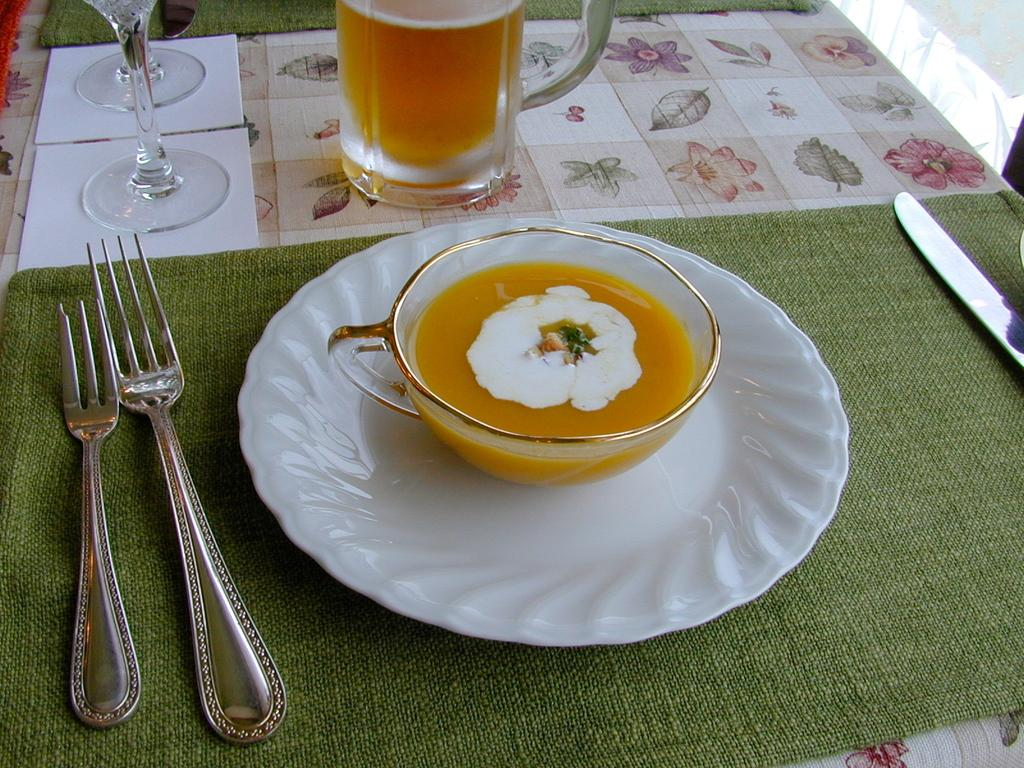What piece of furniture is present in the image? There is a table in the image. What is placed on the table? There is a plate, glasses, forks, a knife, and napkins on the table. What type of food is visible in the image? There is soup in the image. What type of beverage is visible in the image? There is a drink in the image. Can you see any boots in the image? There are no boots present in the image. What type of blow is being delivered in the image? There is no blow being delivered in the image; it is a still image of a table setting. 